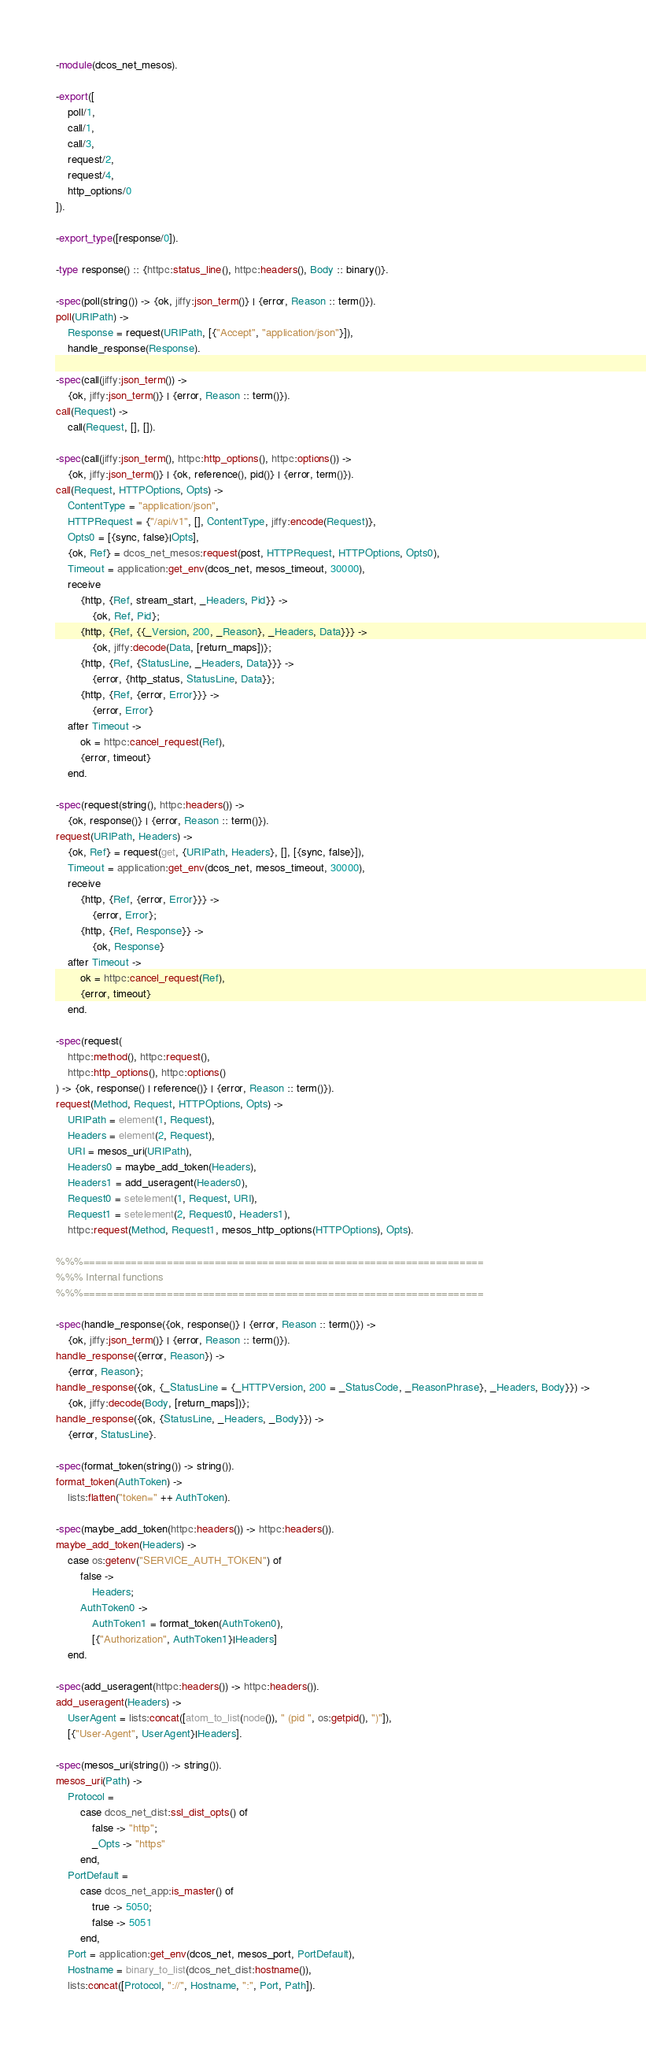<code> <loc_0><loc_0><loc_500><loc_500><_Erlang_>-module(dcos_net_mesos).

-export([
    poll/1,
    call/1,
    call/3,
    request/2,
    request/4,
    http_options/0
]).

-export_type([response/0]).

-type response() :: {httpc:status_line(), httpc:headers(), Body :: binary()}.

-spec(poll(string()) -> {ok, jiffy:json_term()} | {error, Reason :: term()}).
poll(URIPath) ->
    Response = request(URIPath, [{"Accept", "application/json"}]),
    handle_response(Response).

-spec(call(jiffy:json_term()) ->
    {ok, jiffy:json_term()} | {error, Reason :: term()}).
call(Request) ->
    call(Request, [], []).

-spec(call(jiffy:json_term(), httpc:http_options(), httpc:options()) ->
    {ok, jiffy:json_term()} | {ok, reference(), pid()} | {error, term()}).
call(Request, HTTPOptions, Opts) ->
    ContentType = "application/json",
    HTTPRequest = {"/api/v1", [], ContentType, jiffy:encode(Request)},
    Opts0 = [{sync, false}|Opts],
    {ok, Ref} = dcos_net_mesos:request(post, HTTPRequest, HTTPOptions, Opts0),
    Timeout = application:get_env(dcos_net, mesos_timeout, 30000),
    receive
        {http, {Ref, stream_start, _Headers, Pid}} ->
            {ok, Ref, Pid};
        {http, {Ref, {{_Version, 200, _Reason}, _Headers, Data}}} ->
            {ok, jiffy:decode(Data, [return_maps])};
        {http, {Ref, {StatusLine, _Headers, Data}}} ->
            {error, {http_status, StatusLine, Data}};
        {http, {Ref, {error, Error}}} ->
            {error, Error}
    after Timeout ->
        ok = httpc:cancel_request(Ref),
        {error, timeout}
    end.

-spec(request(string(), httpc:headers()) ->
    {ok, response()} | {error, Reason :: term()}).
request(URIPath, Headers) ->
    {ok, Ref} = request(get, {URIPath, Headers}, [], [{sync, false}]),
    Timeout = application:get_env(dcos_net, mesos_timeout, 30000),
    receive
        {http, {Ref, {error, Error}}} ->
            {error, Error};
        {http, {Ref, Response}} ->
            {ok, Response}
    after Timeout ->
        ok = httpc:cancel_request(Ref),
        {error, timeout}
    end.

-spec(request(
    httpc:method(), httpc:request(),
    httpc:http_options(), httpc:options()
) -> {ok, response() | reference()} | {error, Reason :: term()}).
request(Method, Request, HTTPOptions, Opts) ->
    URIPath = element(1, Request),
    Headers = element(2, Request),
    URI = mesos_uri(URIPath),
    Headers0 = maybe_add_token(Headers),
    Headers1 = add_useragent(Headers0),
    Request0 = setelement(1, Request, URI),
    Request1 = setelement(2, Request0, Headers1),
    httpc:request(Method, Request1, mesos_http_options(HTTPOptions), Opts).

%%%===================================================================
%%% Internal functions
%%%===================================================================

-spec(handle_response({ok, response()} | {error, Reason :: term()}) ->
    {ok, jiffy:json_term()} | {error, Reason :: term()}).
handle_response({error, Reason}) ->
    {error, Reason};
handle_response({ok, {_StatusLine = {_HTTPVersion, 200 = _StatusCode, _ReasonPhrase}, _Headers, Body}}) ->
    {ok, jiffy:decode(Body, [return_maps])};
handle_response({ok, {StatusLine, _Headers, _Body}}) ->
    {error, StatusLine}.

-spec(format_token(string()) -> string()).
format_token(AuthToken) ->
    lists:flatten("token=" ++ AuthToken).

-spec(maybe_add_token(httpc:headers()) -> httpc:headers()).
maybe_add_token(Headers) ->
    case os:getenv("SERVICE_AUTH_TOKEN") of
        false ->
            Headers;
        AuthToken0 ->
            AuthToken1 = format_token(AuthToken0),
            [{"Authorization", AuthToken1}|Headers]
    end.

-spec(add_useragent(httpc:headers()) -> httpc:headers()).
add_useragent(Headers) ->
    UserAgent = lists:concat([atom_to_list(node()), " (pid ", os:getpid(), ")"]),
    [{"User-Agent", UserAgent}|Headers].

-spec(mesos_uri(string()) -> string()).
mesos_uri(Path) ->
    Protocol =
        case dcos_net_dist:ssl_dist_opts() of
            false -> "http";
            _Opts -> "https"
        end,
    PortDefault =
        case dcos_net_app:is_master() of
            true -> 5050;
            false -> 5051
        end,
    Port = application:get_env(dcos_net, mesos_port, PortDefault),
    Hostname = binary_to_list(dcos_net_dist:hostname()),
    lists:concat([Protocol, "://", Hostname, ":", Port, Path]).
</code> 